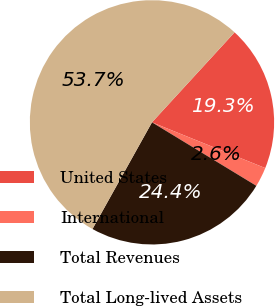Convert chart to OTSL. <chart><loc_0><loc_0><loc_500><loc_500><pie_chart><fcel>United States<fcel>International<fcel>Total Revenues<fcel>Total Long-lived Assets<nl><fcel>19.29%<fcel>2.59%<fcel>24.4%<fcel>53.72%<nl></chart> 